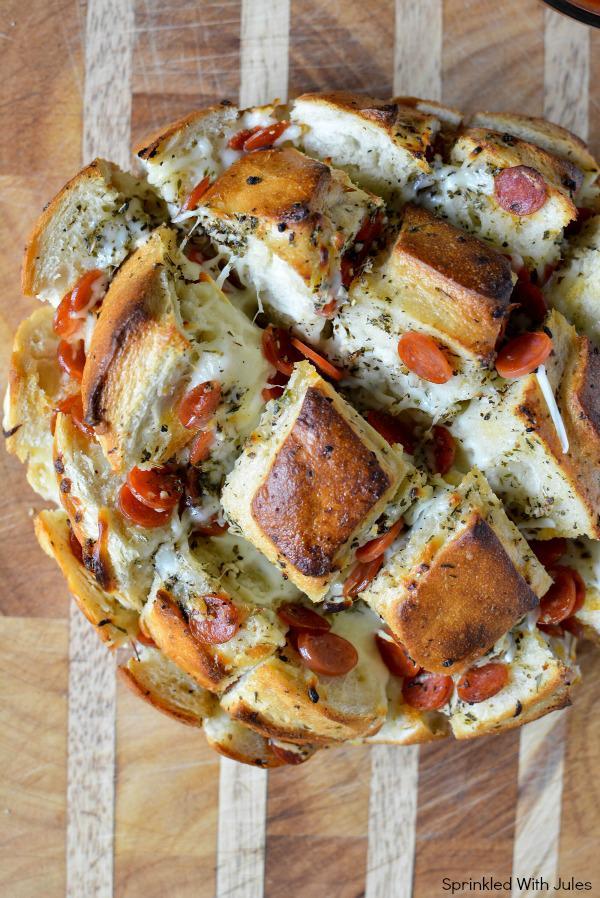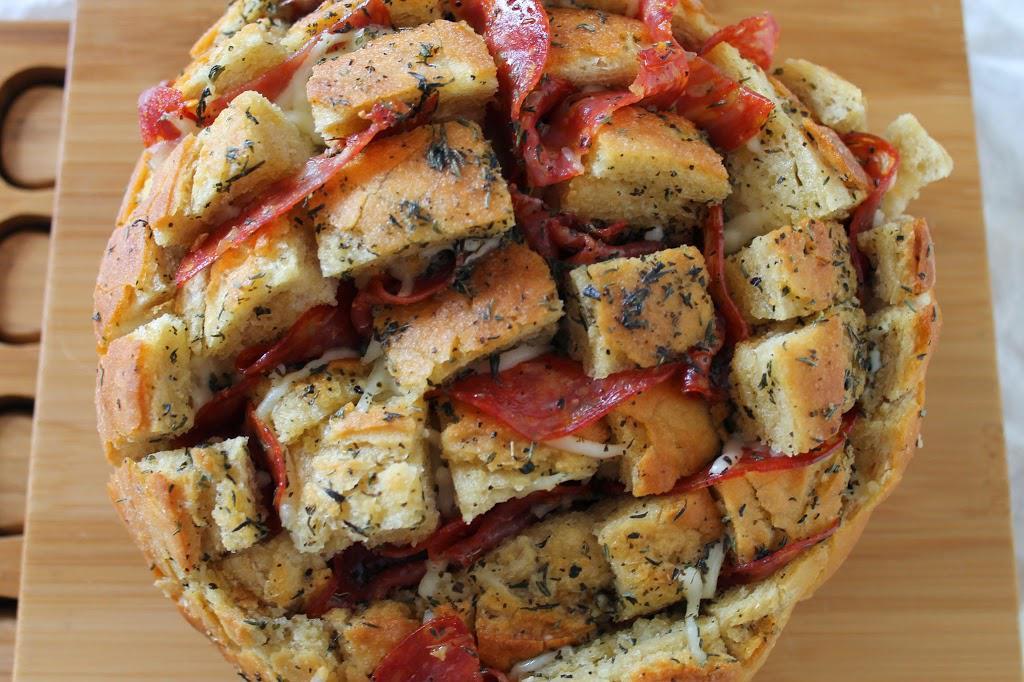The first image is the image on the left, the second image is the image on the right. Analyze the images presented: Is the assertion "IN at least one image there is a pull apart pizza sitting on a black surface." valid? Answer yes or no. No. The first image is the image on the left, the second image is the image on the right. For the images displayed, is the sentence "Both of the pizza breads contain pepperoni." factually correct? Answer yes or no. Yes. 